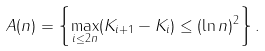<formula> <loc_0><loc_0><loc_500><loc_500>A ( n ) = \left \{ \max _ { i \leq 2 n } ( K _ { i + 1 } - K _ { i } ) \leq ( \ln n ) ^ { 2 } \right \} .</formula> 